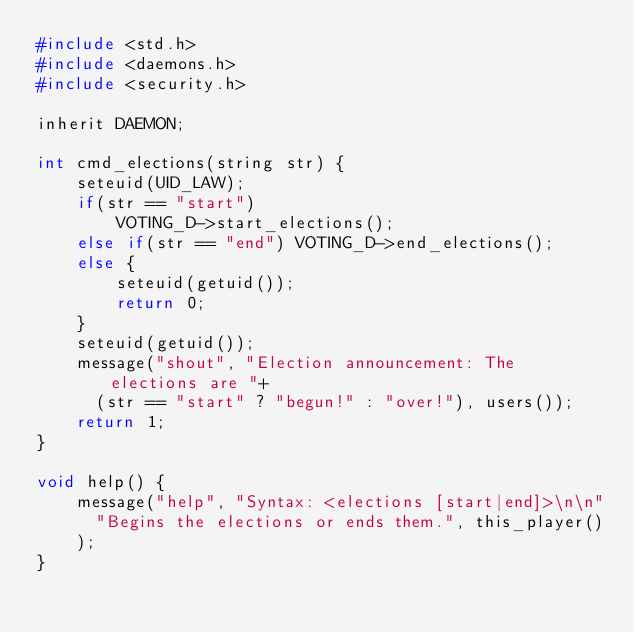<code> <loc_0><loc_0><loc_500><loc_500><_C_>#include <std.h>
#include <daemons.h>
#include <security.h>

inherit DAEMON;

int cmd_elections(string str) {
    seteuid(UID_LAW);
    if(str == "start")
        VOTING_D->start_elections();
    else if(str == "end") VOTING_D->end_elections();
    else {
        seteuid(getuid());
        return 0;
    }
    seteuid(getuid());
    message("shout", "Election announcement: The elections are "+
      (str == "start" ? "begun!" : "over!"), users());
    return 1;
}

void help() {
    message("help", "Syntax: <elections [start|end]>\n\n"
      "Begins the elections or ends them.", this_player()
    );
}
</code> 